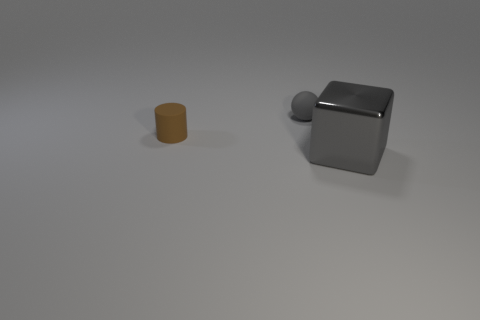What number of brown matte cylinders are left of the brown thing?
Provide a succinct answer. 0. Are there any large gray cubes that have the same material as the ball?
Ensure brevity in your answer.  No. There is a cylinder that is the same size as the gray matte object; what is its material?
Make the answer very short. Rubber. Is the material of the small ball the same as the cylinder?
Your answer should be very brief. Yes. What number of objects are small cyan shiny cylinders or tiny things?
Your answer should be compact. 2. There is a gray thing that is to the left of the big block; what is its shape?
Your response must be concise. Sphere. The ball that is the same material as the brown thing is what color?
Keep it short and to the point. Gray. What is the shape of the metallic object?
Make the answer very short. Cube. There is a thing that is in front of the gray sphere and on the right side of the tiny brown thing; what is its material?
Keep it short and to the point. Metal. The other tiny thing that is made of the same material as the brown object is what shape?
Make the answer very short. Sphere. 